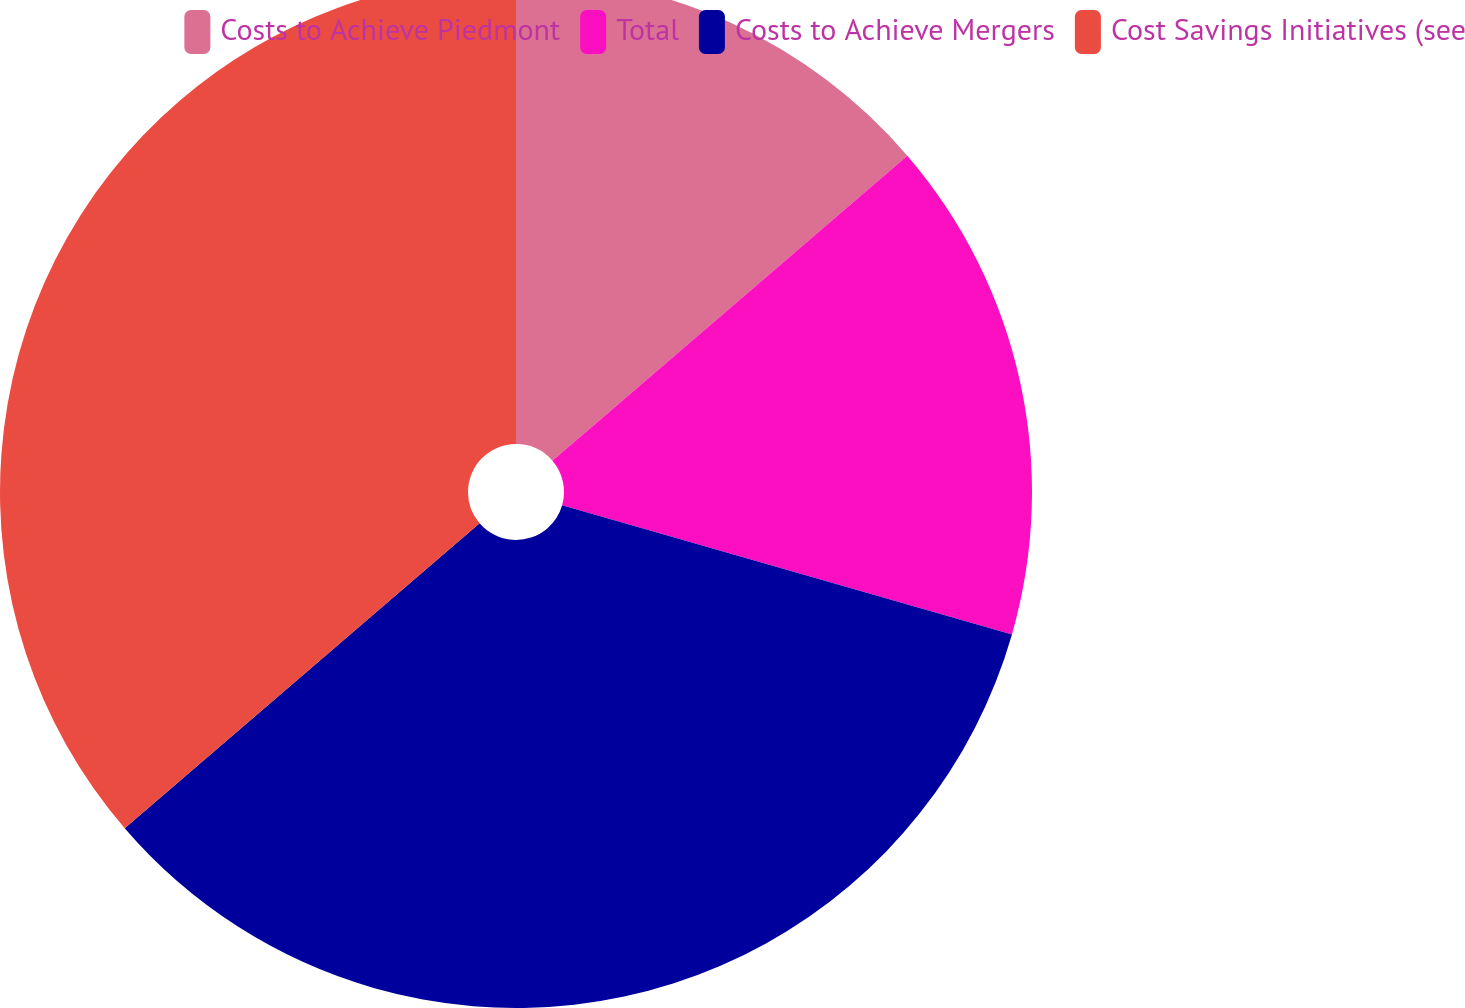Convert chart. <chart><loc_0><loc_0><loc_500><loc_500><pie_chart><fcel>Costs to Achieve Piedmont<fcel>Total<fcel>Costs to Achieve Mergers<fcel>Cost Savings Initiatives (see<nl><fcel>13.7%<fcel>15.75%<fcel>34.25%<fcel>36.3%<nl></chart> 